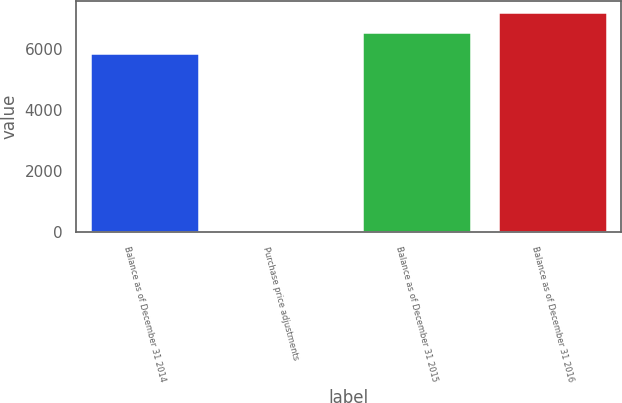Convert chart. <chart><loc_0><loc_0><loc_500><loc_500><bar_chart><fcel>Balance as of December 31 2014<fcel>Purchase price adjustments<fcel>Balance as of December 31 2015<fcel>Balance as of December 31 2016<nl><fcel>5898<fcel>2<fcel>6565.6<fcel>7233.2<nl></chart> 